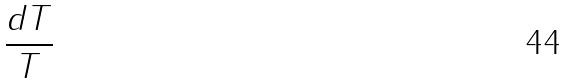Convert formula to latex. <formula><loc_0><loc_0><loc_500><loc_500>\frac { d T } { T }</formula> 